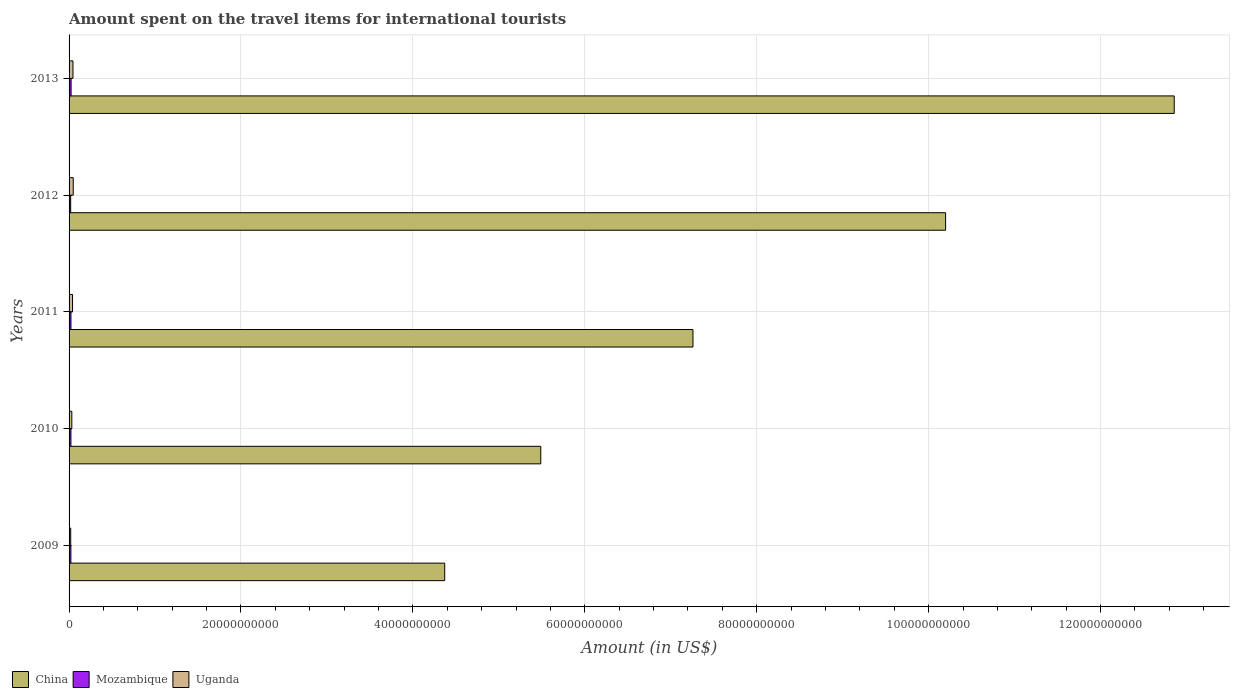How many groups of bars are there?
Give a very brief answer. 5. Are the number of bars per tick equal to the number of legend labels?
Provide a short and direct response. Yes. Are the number of bars on each tick of the Y-axis equal?
Offer a terse response. Yes. How many bars are there on the 5th tick from the top?
Make the answer very short. 3. What is the label of the 3rd group of bars from the top?
Your response must be concise. 2011. What is the amount spent on the travel items for international tourists in Uganda in 2010?
Make the answer very short. 3.20e+08. Across all years, what is the maximum amount spent on the travel items for international tourists in China?
Your answer should be compact. 1.29e+11. Across all years, what is the minimum amount spent on the travel items for international tourists in China?
Offer a very short reply. 4.37e+1. In which year was the amount spent on the travel items for international tourists in China maximum?
Ensure brevity in your answer.  2013. In which year was the amount spent on the travel items for international tourists in Mozambique minimum?
Give a very brief answer. 2012. What is the total amount spent on the travel items for international tourists in Uganda in the graph?
Offer a terse response. 1.85e+09. What is the difference between the amount spent on the travel items for international tourists in China in 2011 and that in 2012?
Keep it short and to the point. -2.94e+1. What is the difference between the amount spent on the travel items for international tourists in Mozambique in 2013 and the amount spent on the travel items for international tourists in Uganda in 2012?
Offer a very short reply. -2.48e+08. What is the average amount spent on the travel items for international tourists in Mozambique per year?
Give a very brief answer. 2.14e+08. In the year 2012, what is the difference between the amount spent on the travel items for international tourists in China and amount spent on the travel items for international tourists in Mozambique?
Keep it short and to the point. 1.02e+11. What is the ratio of the amount spent on the travel items for international tourists in Mozambique in 2009 to that in 2011?
Your answer should be very brief. 0.97. What is the difference between the highest and the second highest amount spent on the travel items for international tourists in China?
Your answer should be compact. 2.66e+1. What is the difference between the highest and the lowest amount spent on the travel items for international tourists in Uganda?
Provide a succinct answer. 2.92e+08. Is the sum of the amount spent on the travel items for international tourists in Uganda in 2009 and 2010 greater than the maximum amount spent on the travel items for international tourists in Mozambique across all years?
Provide a short and direct response. Yes. What does the 1st bar from the top in 2011 represents?
Offer a very short reply. Uganda. What does the 2nd bar from the bottom in 2010 represents?
Ensure brevity in your answer.  Mozambique. How many years are there in the graph?
Keep it short and to the point. 5. Does the graph contain grids?
Make the answer very short. Yes. How are the legend labels stacked?
Your answer should be very brief. Horizontal. What is the title of the graph?
Ensure brevity in your answer.  Amount spent on the travel items for international tourists. What is the label or title of the Y-axis?
Ensure brevity in your answer.  Years. What is the Amount (in US$) of China in 2009?
Your answer should be very brief. 4.37e+1. What is the Amount (in US$) in Mozambique in 2009?
Offer a terse response. 2.12e+08. What is the Amount (in US$) in Uganda in 2009?
Make the answer very short. 1.92e+08. What is the Amount (in US$) in China in 2010?
Offer a very short reply. 5.49e+1. What is the Amount (in US$) of Mozambique in 2010?
Your answer should be compact. 2.16e+08. What is the Amount (in US$) in Uganda in 2010?
Your response must be concise. 3.20e+08. What is the Amount (in US$) in China in 2011?
Your answer should be compact. 7.26e+1. What is the Amount (in US$) in Mozambique in 2011?
Your response must be concise. 2.19e+08. What is the Amount (in US$) of Uganda in 2011?
Your answer should be very brief. 4.05e+08. What is the Amount (in US$) in China in 2012?
Provide a short and direct response. 1.02e+11. What is the Amount (in US$) of Mozambique in 2012?
Give a very brief answer. 1.86e+08. What is the Amount (in US$) of Uganda in 2012?
Your response must be concise. 4.84e+08. What is the Amount (in US$) of China in 2013?
Provide a short and direct response. 1.29e+11. What is the Amount (in US$) in Mozambique in 2013?
Provide a succinct answer. 2.36e+08. What is the Amount (in US$) in Uganda in 2013?
Your response must be concise. 4.53e+08. Across all years, what is the maximum Amount (in US$) in China?
Your response must be concise. 1.29e+11. Across all years, what is the maximum Amount (in US$) in Mozambique?
Offer a very short reply. 2.36e+08. Across all years, what is the maximum Amount (in US$) in Uganda?
Provide a succinct answer. 4.84e+08. Across all years, what is the minimum Amount (in US$) in China?
Your response must be concise. 4.37e+1. Across all years, what is the minimum Amount (in US$) of Mozambique?
Your answer should be compact. 1.86e+08. Across all years, what is the minimum Amount (in US$) in Uganda?
Offer a terse response. 1.92e+08. What is the total Amount (in US$) of China in the graph?
Ensure brevity in your answer.  4.02e+11. What is the total Amount (in US$) in Mozambique in the graph?
Offer a terse response. 1.07e+09. What is the total Amount (in US$) of Uganda in the graph?
Offer a terse response. 1.85e+09. What is the difference between the Amount (in US$) in China in 2009 and that in 2010?
Offer a terse response. -1.12e+1. What is the difference between the Amount (in US$) in Uganda in 2009 and that in 2010?
Ensure brevity in your answer.  -1.28e+08. What is the difference between the Amount (in US$) of China in 2009 and that in 2011?
Offer a terse response. -2.89e+1. What is the difference between the Amount (in US$) of Mozambique in 2009 and that in 2011?
Your answer should be very brief. -7.00e+06. What is the difference between the Amount (in US$) of Uganda in 2009 and that in 2011?
Your answer should be compact. -2.13e+08. What is the difference between the Amount (in US$) in China in 2009 and that in 2012?
Provide a succinct answer. -5.83e+1. What is the difference between the Amount (in US$) of Mozambique in 2009 and that in 2012?
Your answer should be very brief. 2.60e+07. What is the difference between the Amount (in US$) in Uganda in 2009 and that in 2012?
Ensure brevity in your answer.  -2.92e+08. What is the difference between the Amount (in US$) of China in 2009 and that in 2013?
Give a very brief answer. -8.49e+1. What is the difference between the Amount (in US$) of Mozambique in 2009 and that in 2013?
Ensure brevity in your answer.  -2.40e+07. What is the difference between the Amount (in US$) in Uganda in 2009 and that in 2013?
Provide a succinct answer. -2.61e+08. What is the difference between the Amount (in US$) in China in 2010 and that in 2011?
Your answer should be very brief. -1.77e+1. What is the difference between the Amount (in US$) of Mozambique in 2010 and that in 2011?
Provide a succinct answer. -3.00e+06. What is the difference between the Amount (in US$) in Uganda in 2010 and that in 2011?
Provide a succinct answer. -8.50e+07. What is the difference between the Amount (in US$) in China in 2010 and that in 2012?
Make the answer very short. -4.71e+1. What is the difference between the Amount (in US$) of Mozambique in 2010 and that in 2012?
Your answer should be very brief. 3.00e+07. What is the difference between the Amount (in US$) of Uganda in 2010 and that in 2012?
Provide a succinct answer. -1.64e+08. What is the difference between the Amount (in US$) in China in 2010 and that in 2013?
Give a very brief answer. -7.37e+1. What is the difference between the Amount (in US$) of Mozambique in 2010 and that in 2013?
Give a very brief answer. -2.00e+07. What is the difference between the Amount (in US$) in Uganda in 2010 and that in 2013?
Keep it short and to the point. -1.33e+08. What is the difference between the Amount (in US$) of China in 2011 and that in 2012?
Give a very brief answer. -2.94e+1. What is the difference between the Amount (in US$) in Mozambique in 2011 and that in 2012?
Give a very brief answer. 3.30e+07. What is the difference between the Amount (in US$) in Uganda in 2011 and that in 2012?
Offer a very short reply. -7.90e+07. What is the difference between the Amount (in US$) in China in 2011 and that in 2013?
Your response must be concise. -5.60e+1. What is the difference between the Amount (in US$) in Mozambique in 2011 and that in 2013?
Offer a terse response. -1.70e+07. What is the difference between the Amount (in US$) of Uganda in 2011 and that in 2013?
Your response must be concise. -4.80e+07. What is the difference between the Amount (in US$) in China in 2012 and that in 2013?
Offer a very short reply. -2.66e+1. What is the difference between the Amount (in US$) in Mozambique in 2012 and that in 2013?
Provide a short and direct response. -5.00e+07. What is the difference between the Amount (in US$) of Uganda in 2012 and that in 2013?
Your response must be concise. 3.10e+07. What is the difference between the Amount (in US$) of China in 2009 and the Amount (in US$) of Mozambique in 2010?
Your answer should be very brief. 4.35e+1. What is the difference between the Amount (in US$) in China in 2009 and the Amount (in US$) in Uganda in 2010?
Provide a short and direct response. 4.34e+1. What is the difference between the Amount (in US$) of Mozambique in 2009 and the Amount (in US$) of Uganda in 2010?
Your answer should be very brief. -1.08e+08. What is the difference between the Amount (in US$) of China in 2009 and the Amount (in US$) of Mozambique in 2011?
Make the answer very short. 4.35e+1. What is the difference between the Amount (in US$) of China in 2009 and the Amount (in US$) of Uganda in 2011?
Your answer should be very brief. 4.33e+1. What is the difference between the Amount (in US$) of Mozambique in 2009 and the Amount (in US$) of Uganda in 2011?
Give a very brief answer. -1.93e+08. What is the difference between the Amount (in US$) in China in 2009 and the Amount (in US$) in Mozambique in 2012?
Provide a short and direct response. 4.35e+1. What is the difference between the Amount (in US$) of China in 2009 and the Amount (in US$) of Uganda in 2012?
Your answer should be compact. 4.32e+1. What is the difference between the Amount (in US$) of Mozambique in 2009 and the Amount (in US$) of Uganda in 2012?
Offer a very short reply. -2.72e+08. What is the difference between the Amount (in US$) of China in 2009 and the Amount (in US$) of Mozambique in 2013?
Your answer should be compact. 4.35e+1. What is the difference between the Amount (in US$) in China in 2009 and the Amount (in US$) in Uganda in 2013?
Provide a short and direct response. 4.32e+1. What is the difference between the Amount (in US$) of Mozambique in 2009 and the Amount (in US$) of Uganda in 2013?
Provide a succinct answer. -2.41e+08. What is the difference between the Amount (in US$) of China in 2010 and the Amount (in US$) of Mozambique in 2011?
Provide a short and direct response. 5.47e+1. What is the difference between the Amount (in US$) of China in 2010 and the Amount (in US$) of Uganda in 2011?
Provide a short and direct response. 5.45e+1. What is the difference between the Amount (in US$) in Mozambique in 2010 and the Amount (in US$) in Uganda in 2011?
Offer a very short reply. -1.89e+08. What is the difference between the Amount (in US$) of China in 2010 and the Amount (in US$) of Mozambique in 2012?
Keep it short and to the point. 5.47e+1. What is the difference between the Amount (in US$) of China in 2010 and the Amount (in US$) of Uganda in 2012?
Your response must be concise. 5.44e+1. What is the difference between the Amount (in US$) in Mozambique in 2010 and the Amount (in US$) in Uganda in 2012?
Offer a very short reply. -2.68e+08. What is the difference between the Amount (in US$) in China in 2010 and the Amount (in US$) in Mozambique in 2013?
Your answer should be very brief. 5.46e+1. What is the difference between the Amount (in US$) in China in 2010 and the Amount (in US$) in Uganda in 2013?
Give a very brief answer. 5.44e+1. What is the difference between the Amount (in US$) in Mozambique in 2010 and the Amount (in US$) in Uganda in 2013?
Provide a succinct answer. -2.37e+08. What is the difference between the Amount (in US$) of China in 2011 and the Amount (in US$) of Mozambique in 2012?
Provide a succinct answer. 7.24e+1. What is the difference between the Amount (in US$) in China in 2011 and the Amount (in US$) in Uganda in 2012?
Provide a succinct answer. 7.21e+1. What is the difference between the Amount (in US$) in Mozambique in 2011 and the Amount (in US$) in Uganda in 2012?
Offer a terse response. -2.65e+08. What is the difference between the Amount (in US$) in China in 2011 and the Amount (in US$) in Mozambique in 2013?
Offer a terse response. 7.23e+1. What is the difference between the Amount (in US$) of China in 2011 and the Amount (in US$) of Uganda in 2013?
Offer a very short reply. 7.21e+1. What is the difference between the Amount (in US$) of Mozambique in 2011 and the Amount (in US$) of Uganda in 2013?
Offer a very short reply. -2.34e+08. What is the difference between the Amount (in US$) of China in 2012 and the Amount (in US$) of Mozambique in 2013?
Give a very brief answer. 1.02e+11. What is the difference between the Amount (in US$) of China in 2012 and the Amount (in US$) of Uganda in 2013?
Offer a very short reply. 1.02e+11. What is the difference between the Amount (in US$) of Mozambique in 2012 and the Amount (in US$) of Uganda in 2013?
Your response must be concise. -2.67e+08. What is the average Amount (in US$) of China per year?
Offer a very short reply. 8.03e+1. What is the average Amount (in US$) in Mozambique per year?
Your answer should be compact. 2.14e+08. What is the average Amount (in US$) in Uganda per year?
Keep it short and to the point. 3.71e+08. In the year 2009, what is the difference between the Amount (in US$) in China and Amount (in US$) in Mozambique?
Keep it short and to the point. 4.35e+1. In the year 2009, what is the difference between the Amount (in US$) of China and Amount (in US$) of Uganda?
Your answer should be very brief. 4.35e+1. In the year 2010, what is the difference between the Amount (in US$) in China and Amount (in US$) in Mozambique?
Provide a succinct answer. 5.47e+1. In the year 2010, what is the difference between the Amount (in US$) in China and Amount (in US$) in Uganda?
Make the answer very short. 5.46e+1. In the year 2010, what is the difference between the Amount (in US$) of Mozambique and Amount (in US$) of Uganda?
Ensure brevity in your answer.  -1.04e+08. In the year 2011, what is the difference between the Amount (in US$) of China and Amount (in US$) of Mozambique?
Your answer should be compact. 7.24e+1. In the year 2011, what is the difference between the Amount (in US$) in China and Amount (in US$) in Uganda?
Provide a short and direct response. 7.22e+1. In the year 2011, what is the difference between the Amount (in US$) of Mozambique and Amount (in US$) of Uganda?
Provide a succinct answer. -1.86e+08. In the year 2012, what is the difference between the Amount (in US$) of China and Amount (in US$) of Mozambique?
Provide a succinct answer. 1.02e+11. In the year 2012, what is the difference between the Amount (in US$) of China and Amount (in US$) of Uganda?
Your response must be concise. 1.01e+11. In the year 2012, what is the difference between the Amount (in US$) of Mozambique and Amount (in US$) of Uganda?
Provide a succinct answer. -2.98e+08. In the year 2013, what is the difference between the Amount (in US$) in China and Amount (in US$) in Mozambique?
Ensure brevity in your answer.  1.28e+11. In the year 2013, what is the difference between the Amount (in US$) in China and Amount (in US$) in Uganda?
Offer a very short reply. 1.28e+11. In the year 2013, what is the difference between the Amount (in US$) in Mozambique and Amount (in US$) in Uganda?
Keep it short and to the point. -2.17e+08. What is the ratio of the Amount (in US$) in China in 2009 to that in 2010?
Offer a terse response. 0.8. What is the ratio of the Amount (in US$) in Mozambique in 2009 to that in 2010?
Your answer should be compact. 0.98. What is the ratio of the Amount (in US$) in Uganda in 2009 to that in 2010?
Provide a short and direct response. 0.6. What is the ratio of the Amount (in US$) in China in 2009 to that in 2011?
Provide a short and direct response. 0.6. What is the ratio of the Amount (in US$) of Mozambique in 2009 to that in 2011?
Your answer should be compact. 0.97. What is the ratio of the Amount (in US$) in Uganda in 2009 to that in 2011?
Your answer should be very brief. 0.47. What is the ratio of the Amount (in US$) of China in 2009 to that in 2012?
Offer a very short reply. 0.43. What is the ratio of the Amount (in US$) of Mozambique in 2009 to that in 2012?
Keep it short and to the point. 1.14. What is the ratio of the Amount (in US$) in Uganda in 2009 to that in 2012?
Keep it short and to the point. 0.4. What is the ratio of the Amount (in US$) in China in 2009 to that in 2013?
Offer a very short reply. 0.34. What is the ratio of the Amount (in US$) of Mozambique in 2009 to that in 2013?
Offer a very short reply. 0.9. What is the ratio of the Amount (in US$) in Uganda in 2009 to that in 2013?
Your answer should be very brief. 0.42. What is the ratio of the Amount (in US$) in China in 2010 to that in 2011?
Keep it short and to the point. 0.76. What is the ratio of the Amount (in US$) of Mozambique in 2010 to that in 2011?
Your answer should be very brief. 0.99. What is the ratio of the Amount (in US$) of Uganda in 2010 to that in 2011?
Offer a terse response. 0.79. What is the ratio of the Amount (in US$) of China in 2010 to that in 2012?
Make the answer very short. 0.54. What is the ratio of the Amount (in US$) in Mozambique in 2010 to that in 2012?
Provide a succinct answer. 1.16. What is the ratio of the Amount (in US$) in Uganda in 2010 to that in 2012?
Offer a very short reply. 0.66. What is the ratio of the Amount (in US$) in China in 2010 to that in 2013?
Offer a terse response. 0.43. What is the ratio of the Amount (in US$) of Mozambique in 2010 to that in 2013?
Offer a terse response. 0.92. What is the ratio of the Amount (in US$) of Uganda in 2010 to that in 2013?
Keep it short and to the point. 0.71. What is the ratio of the Amount (in US$) in China in 2011 to that in 2012?
Your answer should be very brief. 0.71. What is the ratio of the Amount (in US$) in Mozambique in 2011 to that in 2012?
Your answer should be very brief. 1.18. What is the ratio of the Amount (in US$) in Uganda in 2011 to that in 2012?
Your answer should be very brief. 0.84. What is the ratio of the Amount (in US$) in China in 2011 to that in 2013?
Offer a terse response. 0.56. What is the ratio of the Amount (in US$) in Mozambique in 2011 to that in 2013?
Ensure brevity in your answer.  0.93. What is the ratio of the Amount (in US$) of Uganda in 2011 to that in 2013?
Offer a terse response. 0.89. What is the ratio of the Amount (in US$) in China in 2012 to that in 2013?
Your answer should be very brief. 0.79. What is the ratio of the Amount (in US$) in Mozambique in 2012 to that in 2013?
Provide a succinct answer. 0.79. What is the ratio of the Amount (in US$) of Uganda in 2012 to that in 2013?
Keep it short and to the point. 1.07. What is the difference between the highest and the second highest Amount (in US$) in China?
Your response must be concise. 2.66e+1. What is the difference between the highest and the second highest Amount (in US$) in Mozambique?
Make the answer very short. 1.70e+07. What is the difference between the highest and the second highest Amount (in US$) of Uganda?
Your answer should be compact. 3.10e+07. What is the difference between the highest and the lowest Amount (in US$) of China?
Offer a terse response. 8.49e+1. What is the difference between the highest and the lowest Amount (in US$) of Mozambique?
Your response must be concise. 5.00e+07. What is the difference between the highest and the lowest Amount (in US$) in Uganda?
Your answer should be compact. 2.92e+08. 